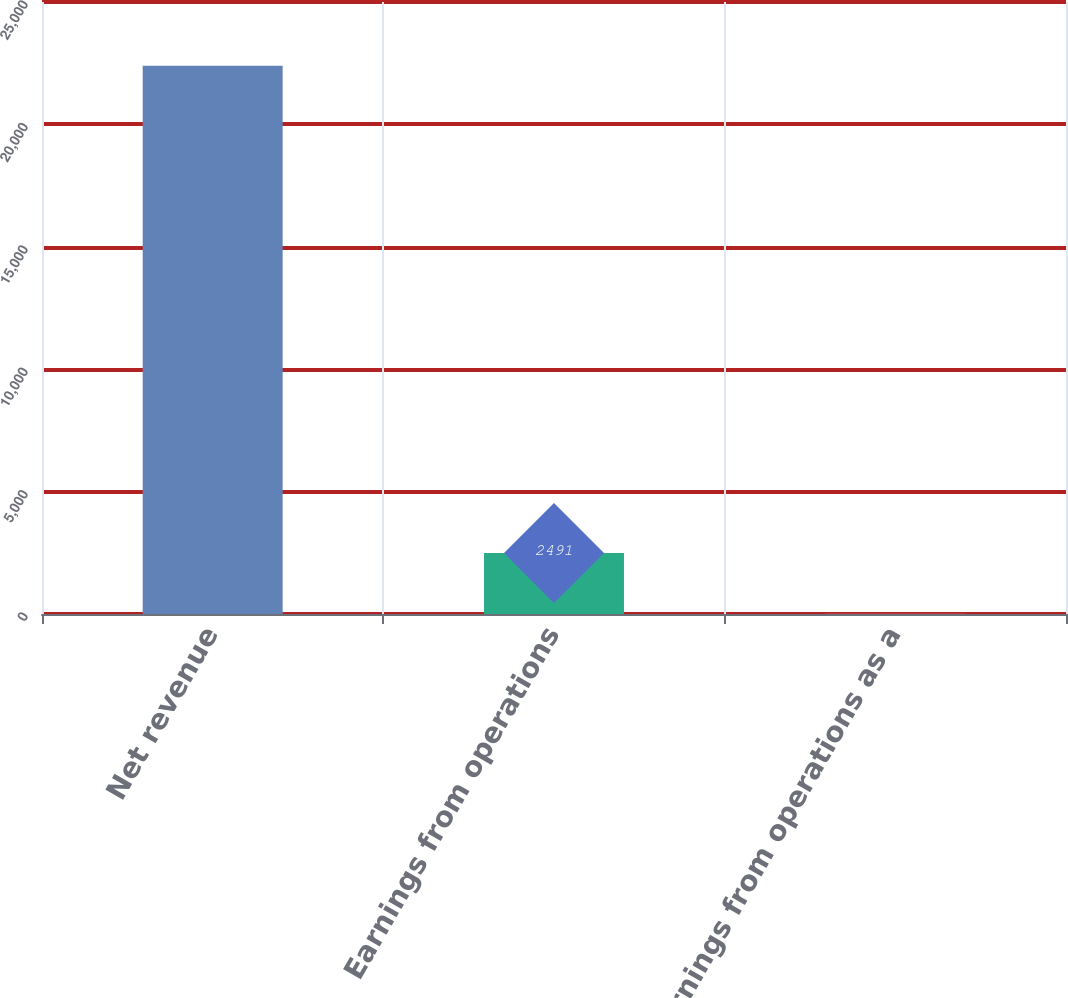<chart> <loc_0><loc_0><loc_500><loc_500><bar_chart><fcel>Net revenue<fcel>Earnings from operations<fcel>Earnings from operations as a<nl><fcel>22397<fcel>2491<fcel>11.1<nl></chart> 